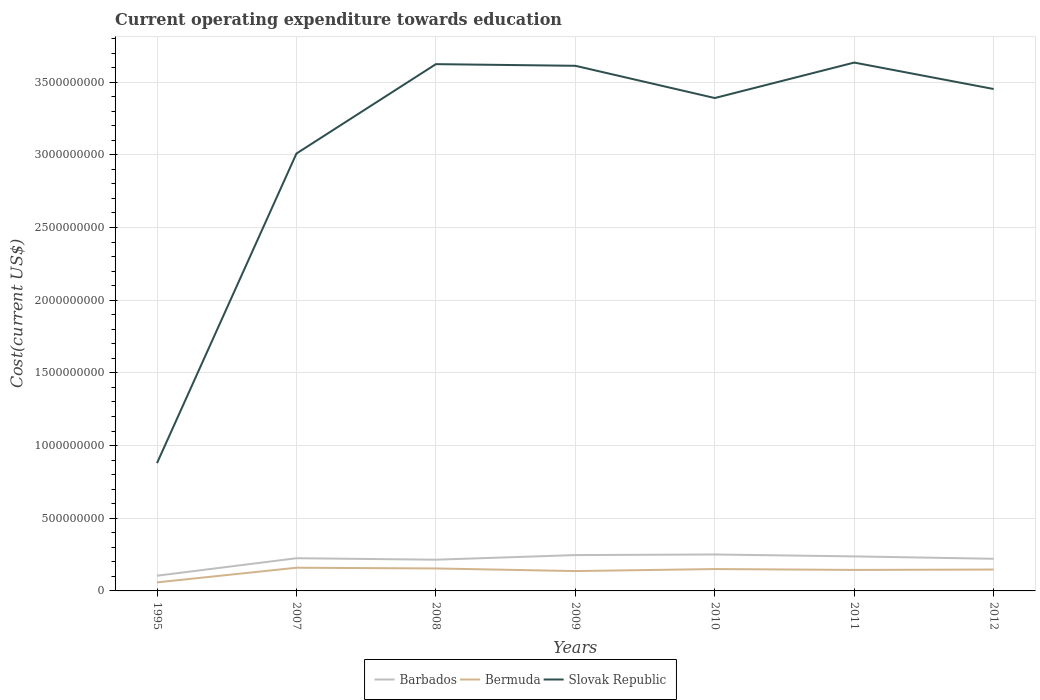How many different coloured lines are there?
Make the answer very short. 3. Does the line corresponding to Barbados intersect with the line corresponding to Bermuda?
Provide a short and direct response. No. Is the number of lines equal to the number of legend labels?
Give a very brief answer. Yes. Across all years, what is the maximum expenditure towards education in Barbados?
Offer a terse response. 1.05e+08. What is the total expenditure towards education in Barbados in the graph?
Offer a very short reply. -3.59e+07. What is the difference between the highest and the second highest expenditure towards education in Slovak Republic?
Provide a short and direct response. 2.76e+09. What is the difference between the highest and the lowest expenditure towards education in Bermuda?
Offer a terse response. 6. Is the expenditure towards education in Barbados strictly greater than the expenditure towards education in Slovak Republic over the years?
Keep it short and to the point. Yes. How many years are there in the graph?
Offer a terse response. 7. What is the difference between two consecutive major ticks on the Y-axis?
Ensure brevity in your answer.  5.00e+08. Are the values on the major ticks of Y-axis written in scientific E-notation?
Make the answer very short. No. Does the graph contain any zero values?
Offer a terse response. No. Where does the legend appear in the graph?
Your answer should be very brief. Bottom center. How many legend labels are there?
Make the answer very short. 3. How are the legend labels stacked?
Your response must be concise. Horizontal. What is the title of the graph?
Offer a very short reply. Current operating expenditure towards education. Does "Israel" appear as one of the legend labels in the graph?
Make the answer very short. No. What is the label or title of the Y-axis?
Offer a very short reply. Cost(current US$). What is the Cost(current US$) of Barbados in 1995?
Keep it short and to the point. 1.05e+08. What is the Cost(current US$) of Bermuda in 1995?
Your response must be concise. 5.87e+07. What is the Cost(current US$) in Slovak Republic in 1995?
Make the answer very short. 8.79e+08. What is the Cost(current US$) of Barbados in 2007?
Provide a short and direct response. 2.25e+08. What is the Cost(current US$) of Bermuda in 2007?
Give a very brief answer. 1.60e+08. What is the Cost(current US$) of Slovak Republic in 2007?
Ensure brevity in your answer.  3.01e+09. What is the Cost(current US$) of Barbados in 2008?
Provide a succinct answer. 2.15e+08. What is the Cost(current US$) of Bermuda in 2008?
Offer a terse response. 1.55e+08. What is the Cost(current US$) in Slovak Republic in 2008?
Provide a short and direct response. 3.62e+09. What is the Cost(current US$) in Barbados in 2009?
Your response must be concise. 2.47e+08. What is the Cost(current US$) in Bermuda in 2009?
Offer a very short reply. 1.36e+08. What is the Cost(current US$) of Slovak Republic in 2009?
Your response must be concise. 3.61e+09. What is the Cost(current US$) of Barbados in 2010?
Provide a short and direct response. 2.51e+08. What is the Cost(current US$) in Bermuda in 2010?
Provide a succinct answer. 1.50e+08. What is the Cost(current US$) of Slovak Republic in 2010?
Keep it short and to the point. 3.39e+09. What is the Cost(current US$) of Barbados in 2011?
Make the answer very short. 2.38e+08. What is the Cost(current US$) of Bermuda in 2011?
Make the answer very short. 1.44e+08. What is the Cost(current US$) of Slovak Republic in 2011?
Your response must be concise. 3.63e+09. What is the Cost(current US$) in Barbados in 2012?
Ensure brevity in your answer.  2.21e+08. What is the Cost(current US$) in Bermuda in 2012?
Give a very brief answer. 1.47e+08. What is the Cost(current US$) in Slovak Republic in 2012?
Provide a succinct answer. 3.45e+09. Across all years, what is the maximum Cost(current US$) of Barbados?
Give a very brief answer. 2.51e+08. Across all years, what is the maximum Cost(current US$) in Bermuda?
Keep it short and to the point. 1.60e+08. Across all years, what is the maximum Cost(current US$) of Slovak Republic?
Your answer should be very brief. 3.63e+09. Across all years, what is the minimum Cost(current US$) of Barbados?
Your answer should be compact. 1.05e+08. Across all years, what is the minimum Cost(current US$) in Bermuda?
Keep it short and to the point. 5.87e+07. Across all years, what is the minimum Cost(current US$) in Slovak Republic?
Your answer should be compact. 8.79e+08. What is the total Cost(current US$) in Barbados in the graph?
Your answer should be compact. 1.50e+09. What is the total Cost(current US$) in Bermuda in the graph?
Provide a succinct answer. 9.51e+08. What is the total Cost(current US$) of Slovak Republic in the graph?
Offer a terse response. 2.16e+1. What is the difference between the Cost(current US$) in Barbados in 1995 and that in 2007?
Provide a succinct answer. -1.20e+08. What is the difference between the Cost(current US$) in Bermuda in 1995 and that in 2007?
Make the answer very short. -1.01e+08. What is the difference between the Cost(current US$) of Slovak Republic in 1995 and that in 2007?
Offer a terse response. -2.13e+09. What is the difference between the Cost(current US$) in Barbados in 1995 and that in 2008?
Provide a succinct answer. -1.10e+08. What is the difference between the Cost(current US$) in Bermuda in 1995 and that in 2008?
Ensure brevity in your answer.  -9.58e+07. What is the difference between the Cost(current US$) in Slovak Republic in 1995 and that in 2008?
Give a very brief answer. -2.74e+09. What is the difference between the Cost(current US$) in Barbados in 1995 and that in 2009?
Make the answer very short. -1.42e+08. What is the difference between the Cost(current US$) of Bermuda in 1995 and that in 2009?
Your response must be concise. -7.78e+07. What is the difference between the Cost(current US$) of Slovak Republic in 1995 and that in 2009?
Make the answer very short. -2.73e+09. What is the difference between the Cost(current US$) in Barbados in 1995 and that in 2010?
Ensure brevity in your answer.  -1.46e+08. What is the difference between the Cost(current US$) in Bermuda in 1995 and that in 2010?
Give a very brief answer. -9.17e+07. What is the difference between the Cost(current US$) in Slovak Republic in 1995 and that in 2010?
Offer a very short reply. -2.51e+09. What is the difference between the Cost(current US$) of Barbados in 1995 and that in 2011?
Provide a succinct answer. -1.33e+08. What is the difference between the Cost(current US$) of Bermuda in 1995 and that in 2011?
Give a very brief answer. -8.57e+07. What is the difference between the Cost(current US$) in Slovak Republic in 1995 and that in 2011?
Your answer should be very brief. -2.76e+09. What is the difference between the Cost(current US$) of Barbados in 1995 and that in 2012?
Make the answer very short. -1.16e+08. What is the difference between the Cost(current US$) in Bermuda in 1995 and that in 2012?
Offer a very short reply. -8.83e+07. What is the difference between the Cost(current US$) of Slovak Republic in 1995 and that in 2012?
Keep it short and to the point. -2.57e+09. What is the difference between the Cost(current US$) of Barbados in 2007 and that in 2008?
Keep it short and to the point. 1.01e+07. What is the difference between the Cost(current US$) of Bermuda in 2007 and that in 2008?
Keep it short and to the point. 5.02e+06. What is the difference between the Cost(current US$) of Slovak Republic in 2007 and that in 2008?
Your answer should be very brief. -6.15e+08. What is the difference between the Cost(current US$) in Barbados in 2007 and that in 2009?
Provide a succinct answer. -2.16e+07. What is the difference between the Cost(current US$) of Bermuda in 2007 and that in 2009?
Your response must be concise. 2.30e+07. What is the difference between the Cost(current US$) of Slovak Republic in 2007 and that in 2009?
Keep it short and to the point. -6.03e+08. What is the difference between the Cost(current US$) in Barbados in 2007 and that in 2010?
Provide a short and direct response. -2.57e+07. What is the difference between the Cost(current US$) in Bermuda in 2007 and that in 2010?
Your answer should be very brief. 9.08e+06. What is the difference between the Cost(current US$) in Slovak Republic in 2007 and that in 2010?
Give a very brief answer. -3.82e+08. What is the difference between the Cost(current US$) of Barbados in 2007 and that in 2011?
Provide a succinct answer. -1.26e+07. What is the difference between the Cost(current US$) in Bermuda in 2007 and that in 2011?
Your answer should be compact. 1.51e+07. What is the difference between the Cost(current US$) of Slovak Republic in 2007 and that in 2011?
Provide a succinct answer. -6.26e+08. What is the difference between the Cost(current US$) in Barbados in 2007 and that in 2012?
Offer a terse response. 3.86e+06. What is the difference between the Cost(current US$) in Bermuda in 2007 and that in 2012?
Offer a very short reply. 1.25e+07. What is the difference between the Cost(current US$) of Slovak Republic in 2007 and that in 2012?
Provide a short and direct response. -4.44e+08. What is the difference between the Cost(current US$) of Barbados in 2008 and that in 2009?
Your answer should be compact. -3.18e+07. What is the difference between the Cost(current US$) in Bermuda in 2008 and that in 2009?
Keep it short and to the point. 1.80e+07. What is the difference between the Cost(current US$) of Slovak Republic in 2008 and that in 2009?
Give a very brief answer. 1.13e+07. What is the difference between the Cost(current US$) in Barbados in 2008 and that in 2010?
Your answer should be compact. -3.59e+07. What is the difference between the Cost(current US$) of Bermuda in 2008 and that in 2010?
Keep it short and to the point. 4.06e+06. What is the difference between the Cost(current US$) in Slovak Republic in 2008 and that in 2010?
Your response must be concise. 2.33e+08. What is the difference between the Cost(current US$) in Barbados in 2008 and that in 2011?
Make the answer very short. -2.28e+07. What is the difference between the Cost(current US$) of Bermuda in 2008 and that in 2011?
Offer a very short reply. 1.01e+07. What is the difference between the Cost(current US$) in Slovak Republic in 2008 and that in 2011?
Offer a terse response. -1.09e+07. What is the difference between the Cost(current US$) of Barbados in 2008 and that in 2012?
Make the answer very short. -6.29e+06. What is the difference between the Cost(current US$) of Bermuda in 2008 and that in 2012?
Provide a succinct answer. 7.46e+06. What is the difference between the Cost(current US$) in Slovak Republic in 2008 and that in 2012?
Your answer should be very brief. 1.71e+08. What is the difference between the Cost(current US$) of Barbados in 2009 and that in 2010?
Provide a short and direct response. -4.12e+06. What is the difference between the Cost(current US$) of Bermuda in 2009 and that in 2010?
Keep it short and to the point. -1.39e+07. What is the difference between the Cost(current US$) of Slovak Republic in 2009 and that in 2010?
Offer a terse response. 2.22e+08. What is the difference between the Cost(current US$) of Barbados in 2009 and that in 2011?
Ensure brevity in your answer.  9.00e+06. What is the difference between the Cost(current US$) in Bermuda in 2009 and that in 2011?
Offer a very short reply. -7.90e+06. What is the difference between the Cost(current US$) in Slovak Republic in 2009 and that in 2011?
Offer a terse response. -2.22e+07. What is the difference between the Cost(current US$) of Barbados in 2009 and that in 2012?
Your answer should be compact. 2.55e+07. What is the difference between the Cost(current US$) in Bermuda in 2009 and that in 2012?
Your answer should be very brief. -1.05e+07. What is the difference between the Cost(current US$) in Slovak Republic in 2009 and that in 2012?
Your answer should be very brief. 1.60e+08. What is the difference between the Cost(current US$) of Barbados in 2010 and that in 2011?
Provide a short and direct response. 1.31e+07. What is the difference between the Cost(current US$) of Bermuda in 2010 and that in 2011?
Ensure brevity in your answer.  6.04e+06. What is the difference between the Cost(current US$) in Slovak Republic in 2010 and that in 2011?
Ensure brevity in your answer.  -2.44e+08. What is the difference between the Cost(current US$) of Barbados in 2010 and that in 2012?
Offer a terse response. 2.96e+07. What is the difference between the Cost(current US$) of Bermuda in 2010 and that in 2012?
Your answer should be very brief. 3.40e+06. What is the difference between the Cost(current US$) in Slovak Republic in 2010 and that in 2012?
Your answer should be compact. -6.19e+07. What is the difference between the Cost(current US$) of Barbados in 2011 and that in 2012?
Keep it short and to the point. 1.65e+07. What is the difference between the Cost(current US$) of Bermuda in 2011 and that in 2012?
Provide a succinct answer. -2.64e+06. What is the difference between the Cost(current US$) of Slovak Republic in 2011 and that in 2012?
Offer a very short reply. 1.82e+08. What is the difference between the Cost(current US$) of Barbados in 1995 and the Cost(current US$) of Bermuda in 2007?
Make the answer very short. -5.49e+07. What is the difference between the Cost(current US$) in Barbados in 1995 and the Cost(current US$) in Slovak Republic in 2007?
Provide a short and direct response. -2.90e+09. What is the difference between the Cost(current US$) of Bermuda in 1995 and the Cost(current US$) of Slovak Republic in 2007?
Provide a short and direct response. -2.95e+09. What is the difference between the Cost(current US$) of Barbados in 1995 and the Cost(current US$) of Bermuda in 2008?
Your answer should be compact. -4.98e+07. What is the difference between the Cost(current US$) of Barbados in 1995 and the Cost(current US$) of Slovak Republic in 2008?
Your answer should be compact. -3.52e+09. What is the difference between the Cost(current US$) in Bermuda in 1995 and the Cost(current US$) in Slovak Republic in 2008?
Provide a succinct answer. -3.56e+09. What is the difference between the Cost(current US$) of Barbados in 1995 and the Cost(current US$) of Bermuda in 2009?
Give a very brief answer. -3.18e+07. What is the difference between the Cost(current US$) in Barbados in 1995 and the Cost(current US$) in Slovak Republic in 2009?
Keep it short and to the point. -3.51e+09. What is the difference between the Cost(current US$) in Bermuda in 1995 and the Cost(current US$) in Slovak Republic in 2009?
Provide a short and direct response. -3.55e+09. What is the difference between the Cost(current US$) of Barbados in 1995 and the Cost(current US$) of Bermuda in 2010?
Ensure brevity in your answer.  -4.58e+07. What is the difference between the Cost(current US$) of Barbados in 1995 and the Cost(current US$) of Slovak Republic in 2010?
Your answer should be compact. -3.29e+09. What is the difference between the Cost(current US$) of Bermuda in 1995 and the Cost(current US$) of Slovak Republic in 2010?
Keep it short and to the point. -3.33e+09. What is the difference between the Cost(current US$) of Barbados in 1995 and the Cost(current US$) of Bermuda in 2011?
Ensure brevity in your answer.  -3.97e+07. What is the difference between the Cost(current US$) in Barbados in 1995 and the Cost(current US$) in Slovak Republic in 2011?
Your response must be concise. -3.53e+09. What is the difference between the Cost(current US$) of Bermuda in 1995 and the Cost(current US$) of Slovak Republic in 2011?
Ensure brevity in your answer.  -3.58e+09. What is the difference between the Cost(current US$) of Barbados in 1995 and the Cost(current US$) of Bermuda in 2012?
Your response must be concise. -4.24e+07. What is the difference between the Cost(current US$) of Barbados in 1995 and the Cost(current US$) of Slovak Republic in 2012?
Provide a succinct answer. -3.35e+09. What is the difference between the Cost(current US$) of Bermuda in 1995 and the Cost(current US$) of Slovak Republic in 2012?
Ensure brevity in your answer.  -3.39e+09. What is the difference between the Cost(current US$) in Barbados in 2007 and the Cost(current US$) in Bermuda in 2008?
Your response must be concise. 7.04e+07. What is the difference between the Cost(current US$) in Barbados in 2007 and the Cost(current US$) in Slovak Republic in 2008?
Provide a short and direct response. -3.40e+09. What is the difference between the Cost(current US$) in Bermuda in 2007 and the Cost(current US$) in Slovak Republic in 2008?
Your answer should be very brief. -3.46e+09. What is the difference between the Cost(current US$) in Barbados in 2007 and the Cost(current US$) in Bermuda in 2009?
Keep it short and to the point. 8.84e+07. What is the difference between the Cost(current US$) in Barbados in 2007 and the Cost(current US$) in Slovak Republic in 2009?
Offer a very short reply. -3.39e+09. What is the difference between the Cost(current US$) in Bermuda in 2007 and the Cost(current US$) in Slovak Republic in 2009?
Give a very brief answer. -3.45e+09. What is the difference between the Cost(current US$) in Barbados in 2007 and the Cost(current US$) in Bermuda in 2010?
Offer a terse response. 7.45e+07. What is the difference between the Cost(current US$) in Barbados in 2007 and the Cost(current US$) in Slovak Republic in 2010?
Provide a succinct answer. -3.17e+09. What is the difference between the Cost(current US$) of Bermuda in 2007 and the Cost(current US$) of Slovak Republic in 2010?
Provide a succinct answer. -3.23e+09. What is the difference between the Cost(current US$) in Barbados in 2007 and the Cost(current US$) in Bermuda in 2011?
Your response must be concise. 8.05e+07. What is the difference between the Cost(current US$) of Barbados in 2007 and the Cost(current US$) of Slovak Republic in 2011?
Offer a very short reply. -3.41e+09. What is the difference between the Cost(current US$) of Bermuda in 2007 and the Cost(current US$) of Slovak Republic in 2011?
Give a very brief answer. -3.47e+09. What is the difference between the Cost(current US$) in Barbados in 2007 and the Cost(current US$) in Bermuda in 2012?
Keep it short and to the point. 7.79e+07. What is the difference between the Cost(current US$) in Barbados in 2007 and the Cost(current US$) in Slovak Republic in 2012?
Your answer should be compact. -3.23e+09. What is the difference between the Cost(current US$) in Bermuda in 2007 and the Cost(current US$) in Slovak Republic in 2012?
Your response must be concise. -3.29e+09. What is the difference between the Cost(current US$) in Barbados in 2008 and the Cost(current US$) in Bermuda in 2009?
Keep it short and to the point. 7.83e+07. What is the difference between the Cost(current US$) in Barbados in 2008 and the Cost(current US$) in Slovak Republic in 2009?
Make the answer very short. -3.40e+09. What is the difference between the Cost(current US$) in Bermuda in 2008 and the Cost(current US$) in Slovak Republic in 2009?
Your response must be concise. -3.46e+09. What is the difference between the Cost(current US$) of Barbados in 2008 and the Cost(current US$) of Bermuda in 2010?
Offer a very short reply. 6.43e+07. What is the difference between the Cost(current US$) in Barbados in 2008 and the Cost(current US$) in Slovak Republic in 2010?
Provide a short and direct response. -3.18e+09. What is the difference between the Cost(current US$) of Bermuda in 2008 and the Cost(current US$) of Slovak Republic in 2010?
Offer a terse response. -3.24e+09. What is the difference between the Cost(current US$) of Barbados in 2008 and the Cost(current US$) of Bermuda in 2011?
Give a very brief answer. 7.04e+07. What is the difference between the Cost(current US$) in Barbados in 2008 and the Cost(current US$) in Slovak Republic in 2011?
Provide a short and direct response. -3.42e+09. What is the difference between the Cost(current US$) in Bermuda in 2008 and the Cost(current US$) in Slovak Republic in 2011?
Ensure brevity in your answer.  -3.48e+09. What is the difference between the Cost(current US$) in Barbados in 2008 and the Cost(current US$) in Bermuda in 2012?
Provide a succinct answer. 6.77e+07. What is the difference between the Cost(current US$) in Barbados in 2008 and the Cost(current US$) in Slovak Republic in 2012?
Your response must be concise. -3.24e+09. What is the difference between the Cost(current US$) in Bermuda in 2008 and the Cost(current US$) in Slovak Republic in 2012?
Provide a succinct answer. -3.30e+09. What is the difference between the Cost(current US$) in Barbados in 2009 and the Cost(current US$) in Bermuda in 2010?
Provide a short and direct response. 9.61e+07. What is the difference between the Cost(current US$) of Barbados in 2009 and the Cost(current US$) of Slovak Republic in 2010?
Keep it short and to the point. -3.14e+09. What is the difference between the Cost(current US$) in Bermuda in 2009 and the Cost(current US$) in Slovak Republic in 2010?
Give a very brief answer. -3.25e+09. What is the difference between the Cost(current US$) in Barbados in 2009 and the Cost(current US$) in Bermuda in 2011?
Keep it short and to the point. 1.02e+08. What is the difference between the Cost(current US$) of Barbados in 2009 and the Cost(current US$) of Slovak Republic in 2011?
Your answer should be very brief. -3.39e+09. What is the difference between the Cost(current US$) of Bermuda in 2009 and the Cost(current US$) of Slovak Republic in 2011?
Provide a short and direct response. -3.50e+09. What is the difference between the Cost(current US$) of Barbados in 2009 and the Cost(current US$) of Bermuda in 2012?
Provide a short and direct response. 9.95e+07. What is the difference between the Cost(current US$) in Barbados in 2009 and the Cost(current US$) in Slovak Republic in 2012?
Ensure brevity in your answer.  -3.21e+09. What is the difference between the Cost(current US$) of Bermuda in 2009 and the Cost(current US$) of Slovak Republic in 2012?
Give a very brief answer. -3.32e+09. What is the difference between the Cost(current US$) of Barbados in 2010 and the Cost(current US$) of Bermuda in 2011?
Give a very brief answer. 1.06e+08. What is the difference between the Cost(current US$) of Barbados in 2010 and the Cost(current US$) of Slovak Republic in 2011?
Your response must be concise. -3.38e+09. What is the difference between the Cost(current US$) of Bermuda in 2010 and the Cost(current US$) of Slovak Republic in 2011?
Your answer should be compact. -3.48e+09. What is the difference between the Cost(current US$) in Barbados in 2010 and the Cost(current US$) in Bermuda in 2012?
Offer a terse response. 1.04e+08. What is the difference between the Cost(current US$) of Barbados in 2010 and the Cost(current US$) of Slovak Republic in 2012?
Offer a terse response. -3.20e+09. What is the difference between the Cost(current US$) in Bermuda in 2010 and the Cost(current US$) in Slovak Republic in 2012?
Give a very brief answer. -3.30e+09. What is the difference between the Cost(current US$) of Barbados in 2011 and the Cost(current US$) of Bermuda in 2012?
Offer a terse response. 9.05e+07. What is the difference between the Cost(current US$) of Barbados in 2011 and the Cost(current US$) of Slovak Republic in 2012?
Your response must be concise. -3.21e+09. What is the difference between the Cost(current US$) of Bermuda in 2011 and the Cost(current US$) of Slovak Republic in 2012?
Your answer should be very brief. -3.31e+09. What is the average Cost(current US$) of Barbados per year?
Provide a succinct answer. 2.14e+08. What is the average Cost(current US$) in Bermuda per year?
Offer a very short reply. 1.36e+08. What is the average Cost(current US$) of Slovak Republic per year?
Offer a very short reply. 3.09e+09. In the year 1995, what is the difference between the Cost(current US$) in Barbados and Cost(current US$) in Bermuda?
Offer a very short reply. 4.59e+07. In the year 1995, what is the difference between the Cost(current US$) in Barbados and Cost(current US$) in Slovak Republic?
Your answer should be compact. -7.74e+08. In the year 1995, what is the difference between the Cost(current US$) in Bermuda and Cost(current US$) in Slovak Republic?
Make the answer very short. -8.20e+08. In the year 2007, what is the difference between the Cost(current US$) of Barbados and Cost(current US$) of Bermuda?
Ensure brevity in your answer.  6.54e+07. In the year 2007, what is the difference between the Cost(current US$) in Barbados and Cost(current US$) in Slovak Republic?
Provide a succinct answer. -2.78e+09. In the year 2007, what is the difference between the Cost(current US$) of Bermuda and Cost(current US$) of Slovak Republic?
Keep it short and to the point. -2.85e+09. In the year 2008, what is the difference between the Cost(current US$) in Barbados and Cost(current US$) in Bermuda?
Your response must be concise. 6.03e+07. In the year 2008, what is the difference between the Cost(current US$) in Barbados and Cost(current US$) in Slovak Republic?
Make the answer very short. -3.41e+09. In the year 2008, what is the difference between the Cost(current US$) in Bermuda and Cost(current US$) in Slovak Republic?
Your answer should be very brief. -3.47e+09. In the year 2009, what is the difference between the Cost(current US$) in Barbados and Cost(current US$) in Bermuda?
Provide a succinct answer. 1.10e+08. In the year 2009, what is the difference between the Cost(current US$) in Barbados and Cost(current US$) in Slovak Republic?
Your response must be concise. -3.37e+09. In the year 2009, what is the difference between the Cost(current US$) of Bermuda and Cost(current US$) of Slovak Republic?
Your response must be concise. -3.48e+09. In the year 2010, what is the difference between the Cost(current US$) in Barbados and Cost(current US$) in Bermuda?
Give a very brief answer. 1.00e+08. In the year 2010, what is the difference between the Cost(current US$) of Barbados and Cost(current US$) of Slovak Republic?
Offer a terse response. -3.14e+09. In the year 2010, what is the difference between the Cost(current US$) of Bermuda and Cost(current US$) of Slovak Republic?
Provide a succinct answer. -3.24e+09. In the year 2011, what is the difference between the Cost(current US$) of Barbados and Cost(current US$) of Bermuda?
Your answer should be very brief. 9.31e+07. In the year 2011, what is the difference between the Cost(current US$) of Barbados and Cost(current US$) of Slovak Republic?
Give a very brief answer. -3.40e+09. In the year 2011, what is the difference between the Cost(current US$) in Bermuda and Cost(current US$) in Slovak Republic?
Your answer should be very brief. -3.49e+09. In the year 2012, what is the difference between the Cost(current US$) in Barbados and Cost(current US$) in Bermuda?
Provide a short and direct response. 7.40e+07. In the year 2012, what is the difference between the Cost(current US$) of Barbados and Cost(current US$) of Slovak Republic?
Provide a succinct answer. -3.23e+09. In the year 2012, what is the difference between the Cost(current US$) in Bermuda and Cost(current US$) in Slovak Republic?
Your response must be concise. -3.31e+09. What is the ratio of the Cost(current US$) in Barbados in 1995 to that in 2007?
Ensure brevity in your answer.  0.47. What is the ratio of the Cost(current US$) of Bermuda in 1995 to that in 2007?
Give a very brief answer. 0.37. What is the ratio of the Cost(current US$) of Slovak Republic in 1995 to that in 2007?
Ensure brevity in your answer.  0.29. What is the ratio of the Cost(current US$) of Barbados in 1995 to that in 2008?
Offer a terse response. 0.49. What is the ratio of the Cost(current US$) in Bermuda in 1995 to that in 2008?
Your answer should be very brief. 0.38. What is the ratio of the Cost(current US$) in Slovak Republic in 1995 to that in 2008?
Your answer should be very brief. 0.24. What is the ratio of the Cost(current US$) of Barbados in 1995 to that in 2009?
Make the answer very short. 0.42. What is the ratio of the Cost(current US$) of Bermuda in 1995 to that in 2009?
Your response must be concise. 0.43. What is the ratio of the Cost(current US$) of Slovak Republic in 1995 to that in 2009?
Keep it short and to the point. 0.24. What is the ratio of the Cost(current US$) of Barbados in 1995 to that in 2010?
Provide a succinct answer. 0.42. What is the ratio of the Cost(current US$) of Bermuda in 1995 to that in 2010?
Your answer should be compact. 0.39. What is the ratio of the Cost(current US$) of Slovak Republic in 1995 to that in 2010?
Your response must be concise. 0.26. What is the ratio of the Cost(current US$) in Barbados in 1995 to that in 2011?
Keep it short and to the point. 0.44. What is the ratio of the Cost(current US$) in Bermuda in 1995 to that in 2011?
Offer a very short reply. 0.41. What is the ratio of the Cost(current US$) of Slovak Republic in 1995 to that in 2011?
Ensure brevity in your answer.  0.24. What is the ratio of the Cost(current US$) of Barbados in 1995 to that in 2012?
Ensure brevity in your answer.  0.47. What is the ratio of the Cost(current US$) in Bermuda in 1995 to that in 2012?
Make the answer very short. 0.4. What is the ratio of the Cost(current US$) in Slovak Republic in 1995 to that in 2012?
Keep it short and to the point. 0.25. What is the ratio of the Cost(current US$) in Barbados in 2007 to that in 2008?
Keep it short and to the point. 1.05. What is the ratio of the Cost(current US$) of Bermuda in 2007 to that in 2008?
Offer a terse response. 1.03. What is the ratio of the Cost(current US$) of Slovak Republic in 2007 to that in 2008?
Ensure brevity in your answer.  0.83. What is the ratio of the Cost(current US$) of Barbados in 2007 to that in 2009?
Ensure brevity in your answer.  0.91. What is the ratio of the Cost(current US$) of Bermuda in 2007 to that in 2009?
Ensure brevity in your answer.  1.17. What is the ratio of the Cost(current US$) in Slovak Republic in 2007 to that in 2009?
Your response must be concise. 0.83. What is the ratio of the Cost(current US$) of Barbados in 2007 to that in 2010?
Your answer should be compact. 0.9. What is the ratio of the Cost(current US$) of Bermuda in 2007 to that in 2010?
Make the answer very short. 1.06. What is the ratio of the Cost(current US$) of Slovak Republic in 2007 to that in 2010?
Provide a short and direct response. 0.89. What is the ratio of the Cost(current US$) in Barbados in 2007 to that in 2011?
Offer a very short reply. 0.95. What is the ratio of the Cost(current US$) in Bermuda in 2007 to that in 2011?
Your answer should be very brief. 1.1. What is the ratio of the Cost(current US$) in Slovak Republic in 2007 to that in 2011?
Ensure brevity in your answer.  0.83. What is the ratio of the Cost(current US$) of Barbados in 2007 to that in 2012?
Provide a succinct answer. 1.02. What is the ratio of the Cost(current US$) in Bermuda in 2007 to that in 2012?
Ensure brevity in your answer.  1.08. What is the ratio of the Cost(current US$) of Slovak Republic in 2007 to that in 2012?
Your answer should be very brief. 0.87. What is the ratio of the Cost(current US$) in Barbados in 2008 to that in 2009?
Offer a very short reply. 0.87. What is the ratio of the Cost(current US$) of Bermuda in 2008 to that in 2009?
Your answer should be compact. 1.13. What is the ratio of the Cost(current US$) of Slovak Republic in 2008 to that in 2009?
Your answer should be compact. 1. What is the ratio of the Cost(current US$) of Barbados in 2008 to that in 2010?
Offer a very short reply. 0.86. What is the ratio of the Cost(current US$) in Bermuda in 2008 to that in 2010?
Your answer should be very brief. 1.03. What is the ratio of the Cost(current US$) in Slovak Republic in 2008 to that in 2010?
Your answer should be very brief. 1.07. What is the ratio of the Cost(current US$) in Barbados in 2008 to that in 2011?
Provide a short and direct response. 0.9. What is the ratio of the Cost(current US$) in Bermuda in 2008 to that in 2011?
Make the answer very short. 1.07. What is the ratio of the Cost(current US$) in Slovak Republic in 2008 to that in 2011?
Keep it short and to the point. 1. What is the ratio of the Cost(current US$) in Barbados in 2008 to that in 2012?
Make the answer very short. 0.97. What is the ratio of the Cost(current US$) in Bermuda in 2008 to that in 2012?
Offer a very short reply. 1.05. What is the ratio of the Cost(current US$) of Slovak Republic in 2008 to that in 2012?
Provide a succinct answer. 1.05. What is the ratio of the Cost(current US$) in Barbados in 2009 to that in 2010?
Your answer should be compact. 0.98. What is the ratio of the Cost(current US$) in Bermuda in 2009 to that in 2010?
Give a very brief answer. 0.91. What is the ratio of the Cost(current US$) in Slovak Republic in 2009 to that in 2010?
Your response must be concise. 1.07. What is the ratio of the Cost(current US$) in Barbados in 2009 to that in 2011?
Keep it short and to the point. 1.04. What is the ratio of the Cost(current US$) in Bermuda in 2009 to that in 2011?
Offer a terse response. 0.95. What is the ratio of the Cost(current US$) in Slovak Republic in 2009 to that in 2011?
Give a very brief answer. 0.99. What is the ratio of the Cost(current US$) in Barbados in 2009 to that in 2012?
Your response must be concise. 1.12. What is the ratio of the Cost(current US$) in Bermuda in 2009 to that in 2012?
Your answer should be very brief. 0.93. What is the ratio of the Cost(current US$) of Slovak Republic in 2009 to that in 2012?
Ensure brevity in your answer.  1.05. What is the ratio of the Cost(current US$) in Barbados in 2010 to that in 2011?
Your answer should be very brief. 1.06. What is the ratio of the Cost(current US$) in Bermuda in 2010 to that in 2011?
Your response must be concise. 1.04. What is the ratio of the Cost(current US$) in Slovak Republic in 2010 to that in 2011?
Provide a short and direct response. 0.93. What is the ratio of the Cost(current US$) of Barbados in 2010 to that in 2012?
Ensure brevity in your answer.  1.13. What is the ratio of the Cost(current US$) of Bermuda in 2010 to that in 2012?
Make the answer very short. 1.02. What is the ratio of the Cost(current US$) in Slovak Republic in 2010 to that in 2012?
Provide a short and direct response. 0.98. What is the ratio of the Cost(current US$) in Barbados in 2011 to that in 2012?
Offer a terse response. 1.07. What is the ratio of the Cost(current US$) in Slovak Republic in 2011 to that in 2012?
Your answer should be compact. 1.05. What is the difference between the highest and the second highest Cost(current US$) in Barbados?
Offer a terse response. 4.12e+06. What is the difference between the highest and the second highest Cost(current US$) of Bermuda?
Your answer should be very brief. 5.02e+06. What is the difference between the highest and the second highest Cost(current US$) of Slovak Republic?
Provide a short and direct response. 1.09e+07. What is the difference between the highest and the lowest Cost(current US$) in Barbados?
Ensure brevity in your answer.  1.46e+08. What is the difference between the highest and the lowest Cost(current US$) in Bermuda?
Offer a terse response. 1.01e+08. What is the difference between the highest and the lowest Cost(current US$) of Slovak Republic?
Keep it short and to the point. 2.76e+09. 